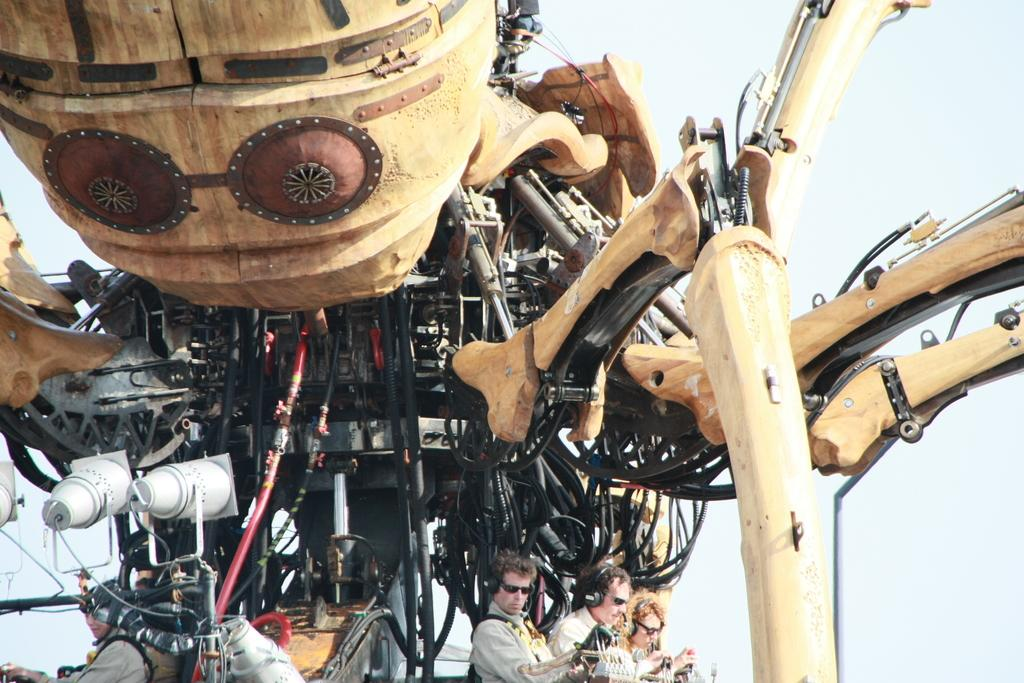What is the main subject of the image? There is an object that resembles a robot in the image. What are the people in the image wearing? The people in the image are wearing headphones. What can be seen in the background of the image? The sky is visible in the background of the image. What type of cave can be seen in the background of the image? There is no cave present in the image; the background features the sky. How does the robot's parent interact with it in the image? There is no indication of a parent or any interaction with the robot in the image. 